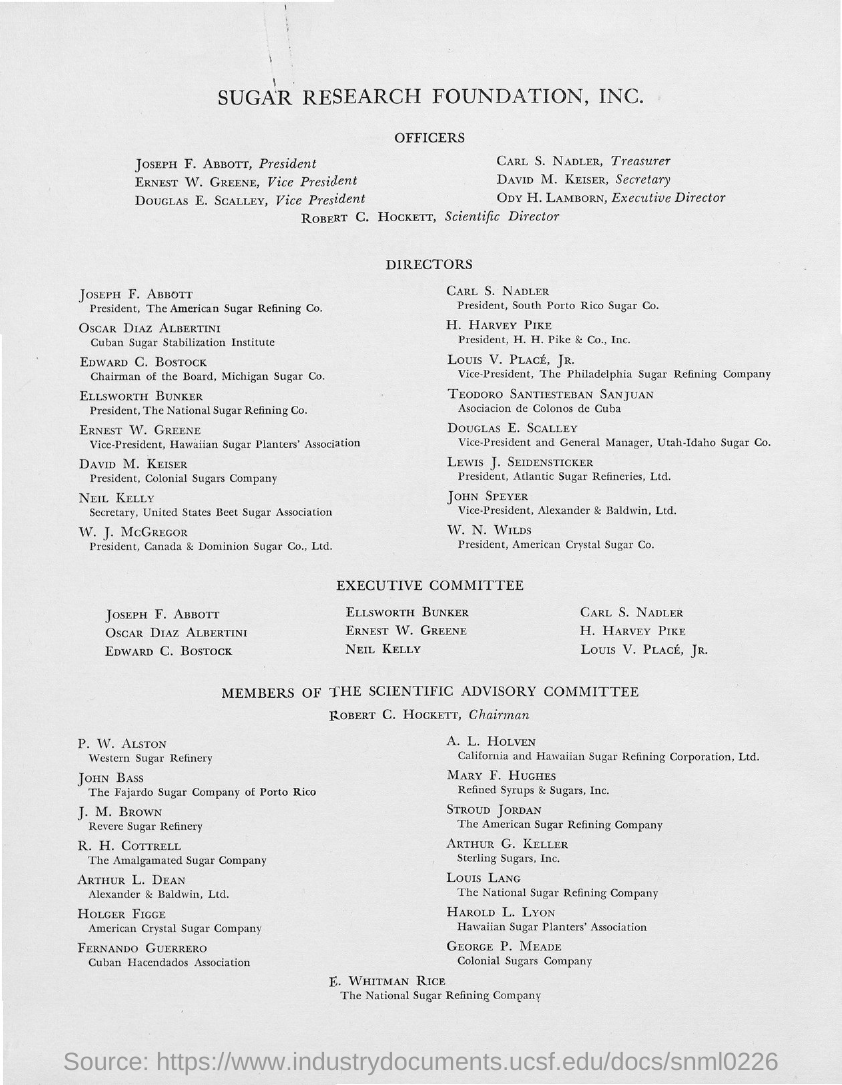Indicate a few pertinent items in this graphic. Joseph F. Abbott is the President. Mr. Douglas E. Scalley holds the position of vice president. I am not sure what you are asking. Could you please provide more context or clarify your question? Ody H. Lamborn holds the position of executive director. David M. Keiser holds the position of Secretary. 